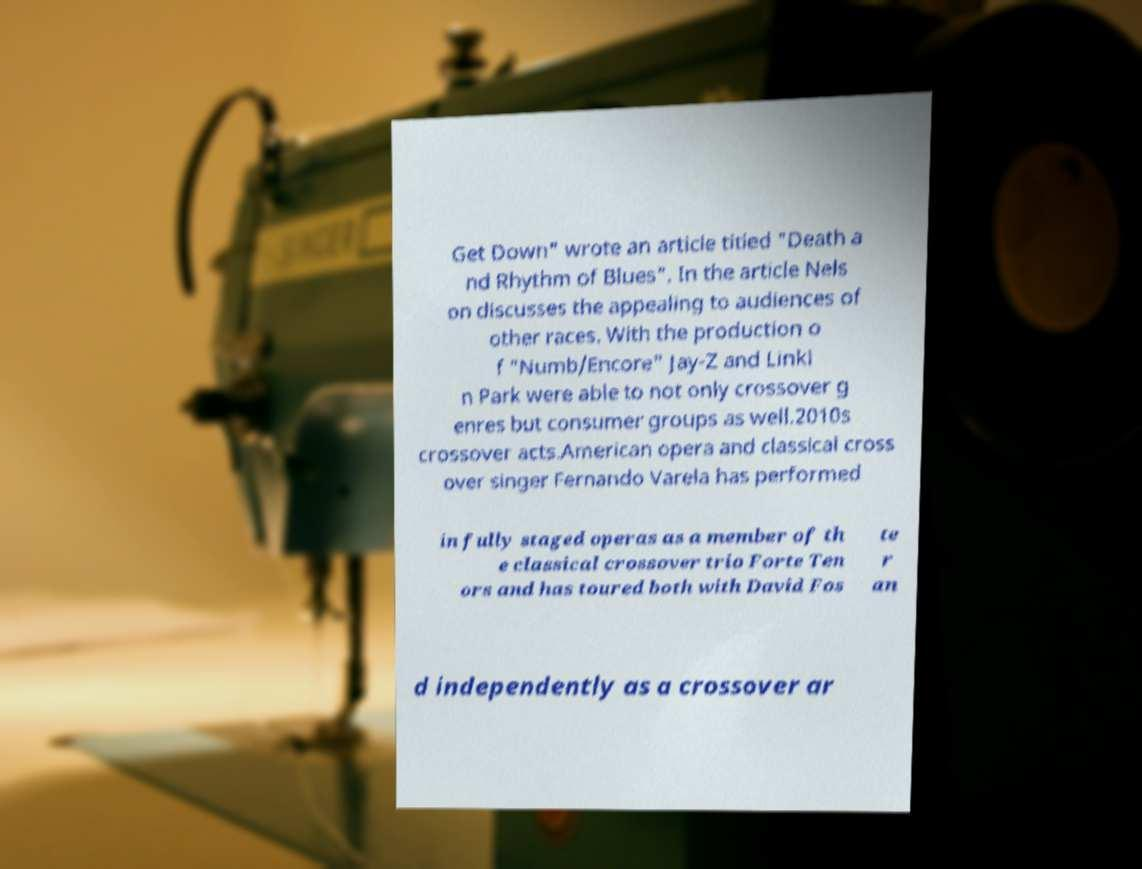What messages or text are displayed in this image? I need them in a readable, typed format. Get Down" wrote an article titled "Death a nd Rhythm of Blues". In the article Nels on discusses the appealing to audiences of other races. With the production o f "Numb/Encore" Jay-Z and Linki n Park were able to not only crossover g enres but consumer groups as well.2010s crossover acts.American opera and classical cross over singer Fernando Varela has performed in fully staged operas as a member of th e classical crossover trio Forte Ten ors and has toured both with David Fos te r an d independently as a crossover ar 